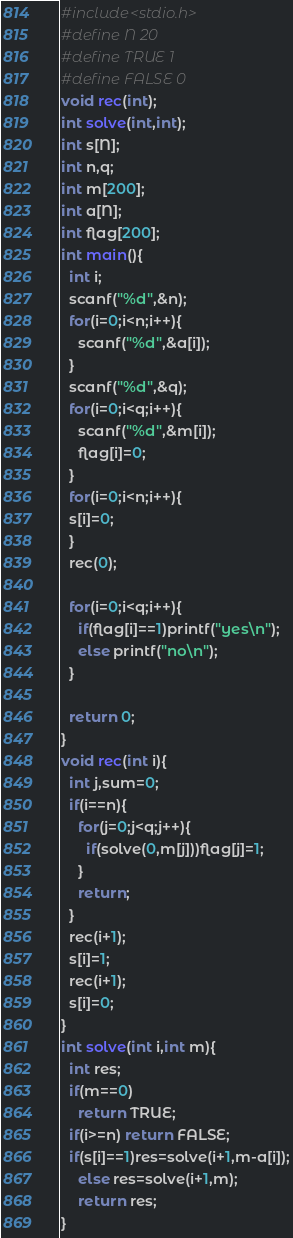Convert code to text. <code><loc_0><loc_0><loc_500><loc_500><_C_>#include<stdio.h>
#define N 20
#define TRUE 1
#define FALSE 0
void rec(int);
int solve(int,int);
int s[N];
int n,q;
int m[200];
int a[N];
int flag[200];
int main(){
  int i;
  scanf("%d",&n);
  for(i=0;i<n;i++){
    scanf("%d",&a[i]);
  }
  scanf("%d",&q);
  for(i=0;i<q;i++){
    scanf("%d",&m[i]);
    flag[i]=0;
  }
  for(i=0;i<n;i++){
  s[i]=0;
  }
  rec(0);
  
  for(i=0;i<q;i++){
    if(flag[i]==1)printf("yes\n");
    else printf("no\n");
  }

  return 0;
}
void rec(int i){
  int j,sum=0;
  if(i==n){
    for(j=0;j<q;j++){
      if(solve(0,m[j]))flag[j]=1;
    }
    return;
  }
  rec(i+1);
  s[i]=1;
  rec(i+1);
  s[i]=0;
}
int solve(int i,int m){
  int res;
  if(m==0)
    return TRUE;
  if(i>=n) return FALSE;
  if(s[i]==1)res=solve(i+1,m-a[i]);
    else res=solve(i+1,m);
    return res;
}

</code> 